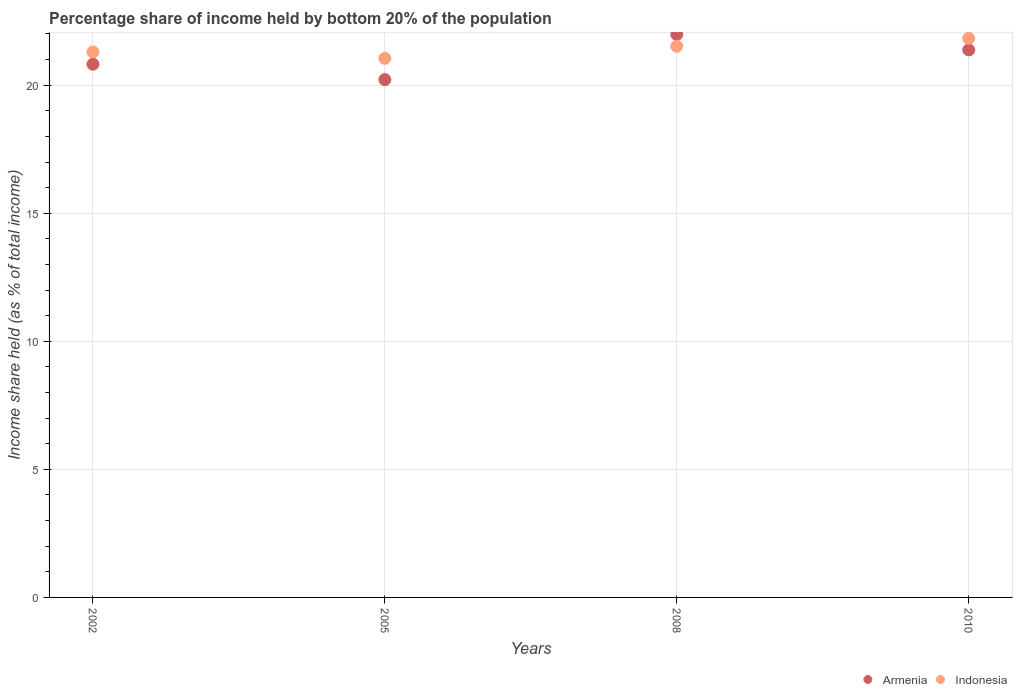Is the number of dotlines equal to the number of legend labels?
Give a very brief answer. Yes. What is the share of income held by bottom 20% of the population in Armenia in 2005?
Keep it short and to the point. 20.22. Across all years, what is the maximum share of income held by bottom 20% of the population in Indonesia?
Offer a very short reply. 21.83. Across all years, what is the minimum share of income held by bottom 20% of the population in Armenia?
Keep it short and to the point. 20.22. In which year was the share of income held by bottom 20% of the population in Indonesia maximum?
Give a very brief answer. 2010. What is the total share of income held by bottom 20% of the population in Indonesia in the graph?
Your answer should be very brief. 85.7. What is the difference between the share of income held by bottom 20% of the population in Indonesia in 2002 and that in 2008?
Offer a terse response. -0.22. What is the difference between the share of income held by bottom 20% of the population in Armenia in 2005 and the share of income held by bottom 20% of the population in Indonesia in 2010?
Ensure brevity in your answer.  -1.61. What is the average share of income held by bottom 20% of the population in Armenia per year?
Ensure brevity in your answer.  21.1. In the year 2002, what is the difference between the share of income held by bottom 20% of the population in Armenia and share of income held by bottom 20% of the population in Indonesia?
Provide a short and direct response. -0.48. What is the ratio of the share of income held by bottom 20% of the population in Armenia in 2002 to that in 2005?
Keep it short and to the point. 1.03. Is the share of income held by bottom 20% of the population in Indonesia in 2005 less than that in 2008?
Your answer should be compact. Yes. Is the difference between the share of income held by bottom 20% of the population in Armenia in 2008 and 2010 greater than the difference between the share of income held by bottom 20% of the population in Indonesia in 2008 and 2010?
Ensure brevity in your answer.  Yes. What is the difference between the highest and the second highest share of income held by bottom 20% of the population in Armenia?
Keep it short and to the point. 0.6. What is the difference between the highest and the lowest share of income held by bottom 20% of the population in Indonesia?
Your answer should be very brief. 0.78. In how many years, is the share of income held by bottom 20% of the population in Indonesia greater than the average share of income held by bottom 20% of the population in Indonesia taken over all years?
Make the answer very short. 2. Does the share of income held by bottom 20% of the population in Indonesia monotonically increase over the years?
Give a very brief answer. No. Is the share of income held by bottom 20% of the population in Armenia strictly less than the share of income held by bottom 20% of the population in Indonesia over the years?
Make the answer very short. No. How many dotlines are there?
Offer a terse response. 2. Are the values on the major ticks of Y-axis written in scientific E-notation?
Offer a terse response. No. Does the graph contain any zero values?
Keep it short and to the point. No. How many legend labels are there?
Keep it short and to the point. 2. What is the title of the graph?
Your answer should be very brief. Percentage share of income held by bottom 20% of the population. Does "Niger" appear as one of the legend labels in the graph?
Your answer should be compact. No. What is the label or title of the X-axis?
Offer a very short reply. Years. What is the label or title of the Y-axis?
Provide a short and direct response. Income share held (as % of total income). What is the Income share held (as % of total income) of Armenia in 2002?
Give a very brief answer. 20.82. What is the Income share held (as % of total income) of Indonesia in 2002?
Give a very brief answer. 21.3. What is the Income share held (as % of total income) of Armenia in 2005?
Ensure brevity in your answer.  20.22. What is the Income share held (as % of total income) of Indonesia in 2005?
Provide a succinct answer. 21.05. What is the Income share held (as % of total income) in Armenia in 2008?
Provide a short and direct response. 21.98. What is the Income share held (as % of total income) of Indonesia in 2008?
Your answer should be very brief. 21.52. What is the Income share held (as % of total income) of Armenia in 2010?
Keep it short and to the point. 21.38. What is the Income share held (as % of total income) in Indonesia in 2010?
Give a very brief answer. 21.83. Across all years, what is the maximum Income share held (as % of total income) of Armenia?
Ensure brevity in your answer.  21.98. Across all years, what is the maximum Income share held (as % of total income) of Indonesia?
Keep it short and to the point. 21.83. Across all years, what is the minimum Income share held (as % of total income) in Armenia?
Provide a short and direct response. 20.22. Across all years, what is the minimum Income share held (as % of total income) of Indonesia?
Offer a terse response. 21.05. What is the total Income share held (as % of total income) in Armenia in the graph?
Your response must be concise. 84.4. What is the total Income share held (as % of total income) in Indonesia in the graph?
Provide a succinct answer. 85.7. What is the difference between the Income share held (as % of total income) of Indonesia in 2002 and that in 2005?
Ensure brevity in your answer.  0.25. What is the difference between the Income share held (as % of total income) in Armenia in 2002 and that in 2008?
Keep it short and to the point. -1.16. What is the difference between the Income share held (as % of total income) in Indonesia in 2002 and that in 2008?
Keep it short and to the point. -0.22. What is the difference between the Income share held (as % of total income) in Armenia in 2002 and that in 2010?
Ensure brevity in your answer.  -0.56. What is the difference between the Income share held (as % of total income) of Indonesia in 2002 and that in 2010?
Your answer should be compact. -0.53. What is the difference between the Income share held (as % of total income) in Armenia in 2005 and that in 2008?
Keep it short and to the point. -1.76. What is the difference between the Income share held (as % of total income) of Indonesia in 2005 and that in 2008?
Make the answer very short. -0.47. What is the difference between the Income share held (as % of total income) of Armenia in 2005 and that in 2010?
Your response must be concise. -1.16. What is the difference between the Income share held (as % of total income) of Indonesia in 2005 and that in 2010?
Your answer should be very brief. -0.78. What is the difference between the Income share held (as % of total income) in Indonesia in 2008 and that in 2010?
Provide a short and direct response. -0.31. What is the difference between the Income share held (as % of total income) in Armenia in 2002 and the Income share held (as % of total income) in Indonesia in 2005?
Provide a succinct answer. -0.23. What is the difference between the Income share held (as % of total income) of Armenia in 2002 and the Income share held (as % of total income) of Indonesia in 2008?
Provide a succinct answer. -0.7. What is the difference between the Income share held (as % of total income) in Armenia in 2002 and the Income share held (as % of total income) in Indonesia in 2010?
Make the answer very short. -1.01. What is the difference between the Income share held (as % of total income) in Armenia in 2005 and the Income share held (as % of total income) in Indonesia in 2008?
Your answer should be compact. -1.3. What is the difference between the Income share held (as % of total income) of Armenia in 2005 and the Income share held (as % of total income) of Indonesia in 2010?
Give a very brief answer. -1.61. What is the average Income share held (as % of total income) in Armenia per year?
Give a very brief answer. 21.1. What is the average Income share held (as % of total income) of Indonesia per year?
Offer a very short reply. 21.43. In the year 2002, what is the difference between the Income share held (as % of total income) in Armenia and Income share held (as % of total income) in Indonesia?
Offer a very short reply. -0.48. In the year 2005, what is the difference between the Income share held (as % of total income) in Armenia and Income share held (as % of total income) in Indonesia?
Offer a very short reply. -0.83. In the year 2008, what is the difference between the Income share held (as % of total income) in Armenia and Income share held (as % of total income) in Indonesia?
Offer a terse response. 0.46. In the year 2010, what is the difference between the Income share held (as % of total income) in Armenia and Income share held (as % of total income) in Indonesia?
Provide a short and direct response. -0.45. What is the ratio of the Income share held (as % of total income) in Armenia in 2002 to that in 2005?
Your response must be concise. 1.03. What is the ratio of the Income share held (as % of total income) of Indonesia in 2002 to that in 2005?
Offer a terse response. 1.01. What is the ratio of the Income share held (as % of total income) of Armenia in 2002 to that in 2008?
Give a very brief answer. 0.95. What is the ratio of the Income share held (as % of total income) in Armenia in 2002 to that in 2010?
Provide a short and direct response. 0.97. What is the ratio of the Income share held (as % of total income) of Indonesia in 2002 to that in 2010?
Your response must be concise. 0.98. What is the ratio of the Income share held (as % of total income) of Armenia in 2005 to that in 2008?
Provide a short and direct response. 0.92. What is the ratio of the Income share held (as % of total income) of Indonesia in 2005 to that in 2008?
Ensure brevity in your answer.  0.98. What is the ratio of the Income share held (as % of total income) in Armenia in 2005 to that in 2010?
Make the answer very short. 0.95. What is the ratio of the Income share held (as % of total income) in Armenia in 2008 to that in 2010?
Make the answer very short. 1.03. What is the ratio of the Income share held (as % of total income) in Indonesia in 2008 to that in 2010?
Your answer should be compact. 0.99. What is the difference between the highest and the second highest Income share held (as % of total income) in Indonesia?
Your response must be concise. 0.31. What is the difference between the highest and the lowest Income share held (as % of total income) in Armenia?
Make the answer very short. 1.76. What is the difference between the highest and the lowest Income share held (as % of total income) in Indonesia?
Keep it short and to the point. 0.78. 